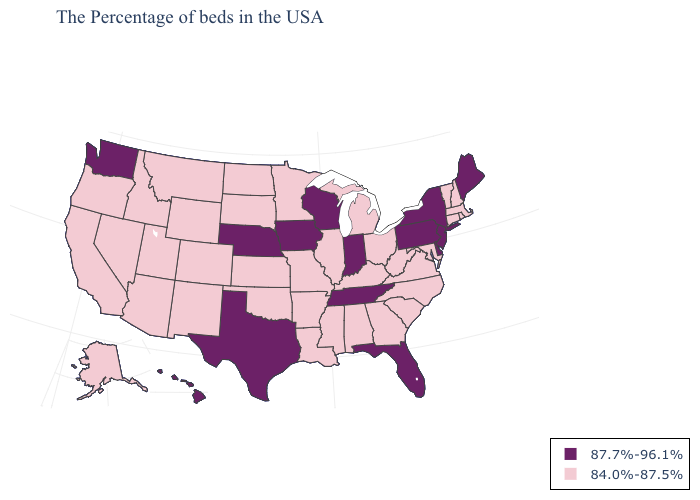Does Ohio have the same value as Nebraska?
Keep it brief. No. Does the map have missing data?
Be succinct. No. Does Indiana have a higher value than Louisiana?
Be succinct. Yes. Name the states that have a value in the range 84.0%-87.5%?
Short answer required. Massachusetts, Rhode Island, New Hampshire, Vermont, Connecticut, Maryland, Virginia, North Carolina, South Carolina, West Virginia, Ohio, Georgia, Michigan, Kentucky, Alabama, Illinois, Mississippi, Louisiana, Missouri, Arkansas, Minnesota, Kansas, Oklahoma, South Dakota, North Dakota, Wyoming, Colorado, New Mexico, Utah, Montana, Arizona, Idaho, Nevada, California, Oregon, Alaska. What is the value of New Hampshire?
Keep it brief. 84.0%-87.5%. Name the states that have a value in the range 84.0%-87.5%?
Answer briefly. Massachusetts, Rhode Island, New Hampshire, Vermont, Connecticut, Maryland, Virginia, North Carolina, South Carolina, West Virginia, Ohio, Georgia, Michigan, Kentucky, Alabama, Illinois, Mississippi, Louisiana, Missouri, Arkansas, Minnesota, Kansas, Oklahoma, South Dakota, North Dakota, Wyoming, Colorado, New Mexico, Utah, Montana, Arizona, Idaho, Nevada, California, Oregon, Alaska. Does Oregon have the lowest value in the West?
Quick response, please. Yes. Does Oklahoma have the same value as Florida?
Quick response, please. No. Does Alabama have the lowest value in the USA?
Write a very short answer. Yes. Name the states that have a value in the range 87.7%-96.1%?
Be succinct. Maine, New York, New Jersey, Delaware, Pennsylvania, Florida, Indiana, Tennessee, Wisconsin, Iowa, Nebraska, Texas, Washington, Hawaii. Which states hav the highest value in the MidWest?
Be succinct. Indiana, Wisconsin, Iowa, Nebraska. Does Tennessee have the highest value in the South?
Be succinct. Yes. Is the legend a continuous bar?
Be succinct. No. What is the highest value in the USA?
Quick response, please. 87.7%-96.1%. What is the value of Ohio?
Give a very brief answer. 84.0%-87.5%. 